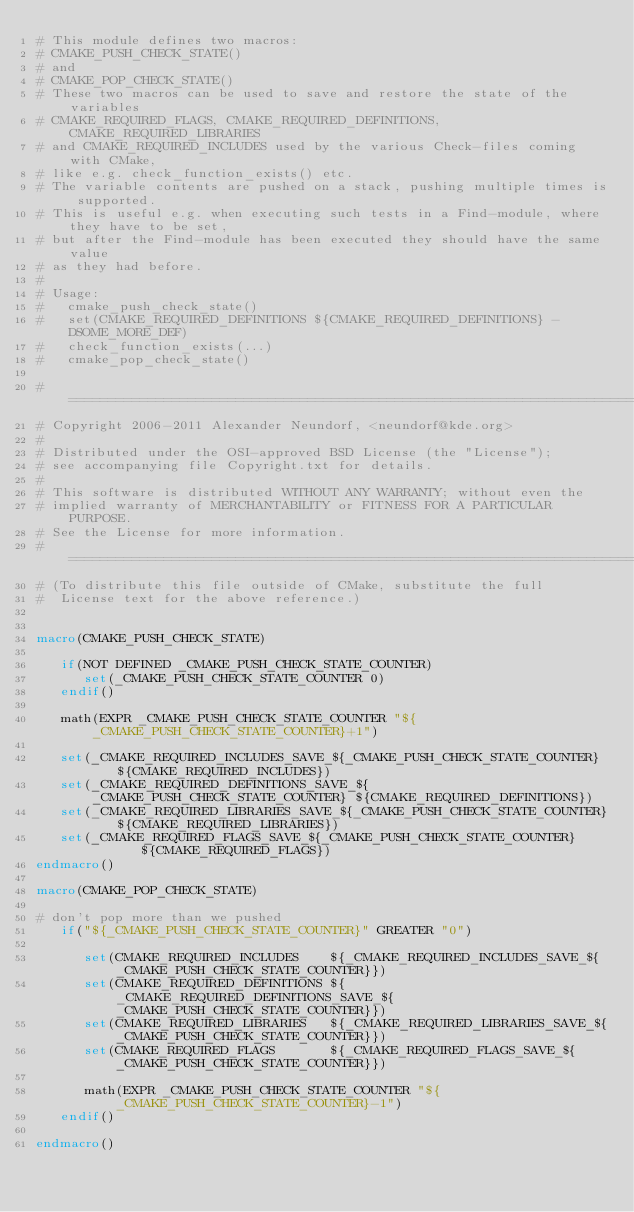<code> <loc_0><loc_0><loc_500><loc_500><_CMake_># This module defines two macros:
# CMAKE_PUSH_CHECK_STATE()
# and
# CMAKE_POP_CHECK_STATE()
# These two macros can be used to save and restore the state of the variables
# CMAKE_REQUIRED_FLAGS, CMAKE_REQUIRED_DEFINITIONS, CMAKE_REQUIRED_LIBRARIES
# and CMAKE_REQUIRED_INCLUDES used by the various Check-files coming with CMake,
# like e.g. check_function_exists() etc.
# The variable contents are pushed on a stack, pushing multiple times is supported.
# This is useful e.g. when executing such tests in a Find-module, where they have to be set,
# but after the Find-module has been executed they should have the same value
# as they had before.
#
# Usage:
#   cmake_push_check_state()
#   set(CMAKE_REQUIRED_DEFINITIONS ${CMAKE_REQUIRED_DEFINITIONS} -DSOME_MORE_DEF)
#   check_function_exists(...)
#   cmake_pop_check_state()

#=============================================================================
# Copyright 2006-2011 Alexander Neundorf, <neundorf@kde.org>
#
# Distributed under the OSI-approved BSD License (the "License");
# see accompanying file Copyright.txt for details.
#
# This software is distributed WITHOUT ANY WARRANTY; without even the
# implied warranty of MERCHANTABILITY or FITNESS FOR A PARTICULAR PURPOSE.
# See the License for more information.
#=============================================================================
# (To distribute this file outside of CMake, substitute the full
#  License text for the above reference.)


macro(CMAKE_PUSH_CHECK_STATE)

   if(NOT DEFINED _CMAKE_PUSH_CHECK_STATE_COUNTER)
      set(_CMAKE_PUSH_CHECK_STATE_COUNTER 0)
   endif()

   math(EXPR _CMAKE_PUSH_CHECK_STATE_COUNTER "${_CMAKE_PUSH_CHECK_STATE_COUNTER}+1")

   set(_CMAKE_REQUIRED_INCLUDES_SAVE_${_CMAKE_PUSH_CHECK_STATE_COUNTER}    ${CMAKE_REQUIRED_INCLUDES})
   set(_CMAKE_REQUIRED_DEFINITIONS_SAVE_${_CMAKE_PUSH_CHECK_STATE_COUNTER} ${CMAKE_REQUIRED_DEFINITIONS})
   set(_CMAKE_REQUIRED_LIBRARIES_SAVE_${_CMAKE_PUSH_CHECK_STATE_COUNTER}   ${CMAKE_REQUIRED_LIBRARIES})
   set(_CMAKE_REQUIRED_FLAGS_SAVE_${_CMAKE_PUSH_CHECK_STATE_COUNTER}       ${CMAKE_REQUIRED_FLAGS})
endmacro()

macro(CMAKE_POP_CHECK_STATE)

# don't pop more than we pushed
   if("${_CMAKE_PUSH_CHECK_STATE_COUNTER}" GREATER "0")

      set(CMAKE_REQUIRED_INCLUDES    ${_CMAKE_REQUIRED_INCLUDES_SAVE_${_CMAKE_PUSH_CHECK_STATE_COUNTER}})
      set(CMAKE_REQUIRED_DEFINITIONS ${_CMAKE_REQUIRED_DEFINITIONS_SAVE_${_CMAKE_PUSH_CHECK_STATE_COUNTER}})
      set(CMAKE_REQUIRED_LIBRARIES   ${_CMAKE_REQUIRED_LIBRARIES_SAVE_${_CMAKE_PUSH_CHECK_STATE_COUNTER}})
      set(CMAKE_REQUIRED_FLAGS       ${_CMAKE_REQUIRED_FLAGS_SAVE_${_CMAKE_PUSH_CHECK_STATE_COUNTER}})

      math(EXPR _CMAKE_PUSH_CHECK_STATE_COUNTER "${_CMAKE_PUSH_CHECK_STATE_COUNTER}-1")
   endif()

endmacro()
</code> 